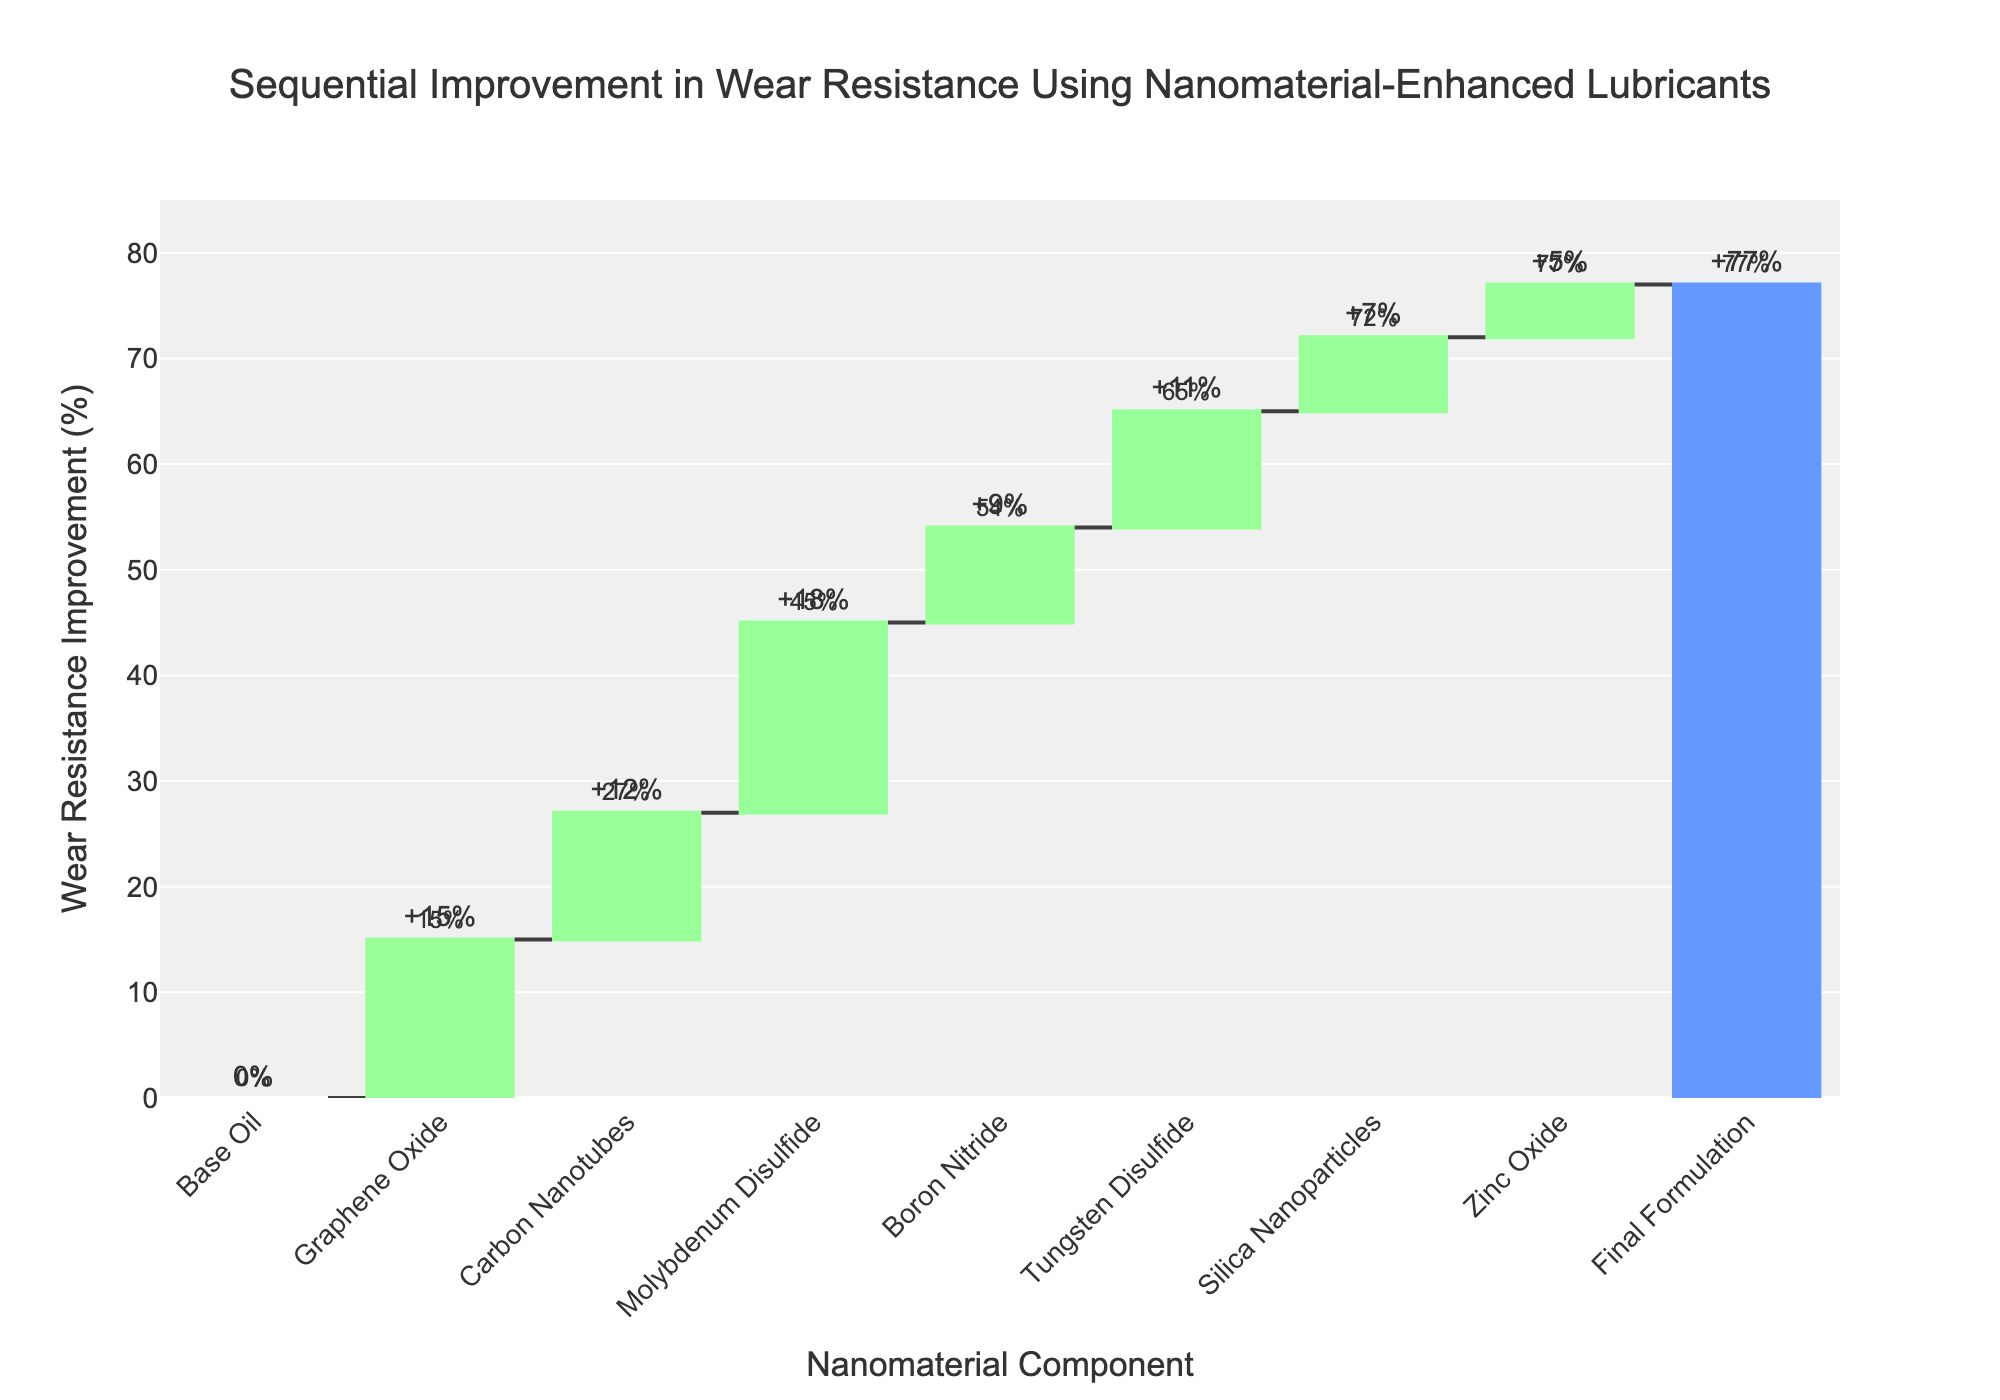What is the title of the chart? The title is usually at the top of the chart. In this case, it reads "Sequential Improvement in Wear Resistance Using Nanomaterial-Enhanced Lubricants".
Answer: Sequential Improvement in Wear Resistance Using Nanomaterial-Enhanced Lubricants What is the total improvement in wear resistance after using all nanomaterial-enhanced lubricants? The total improvement can be found by looking at the last column labeled "Final Formulation", where the text and y-axis both indicate the total improvement in wear resistance.
Answer: 77% Which nanomaterial component contributes the highest percentage improvement in wear resistance? By checking each bar's height or label, you can see that Molybdenum Disulfide has the highest individual percentage improvement at 18%.
Answer: Molybdenum Disulfide What is the combined wear resistance improvement of Carbon Nanotubes and Boron Nitride? Combine the individual improvements: 12% for Carbon Nanotubes and 9% for Boron Nitride to get the total of 21%.
Answer: 21% What is the running total of wear resistance improvement after adding Carbon Nanotubes? According to the "Running Total (%)" value next to Carbon Nanotubes, the cumulative improvement is 27% at this stage.
Answer: 27% Which component showed the least improvement in wear resistance? Comparing all nanomaterial components by their improvement percentages, Zinc Oxide showed the least improvement with just 5%.
Answer: Zinc Oxide What is the difference in wear resistance improvement between Graphene Oxide and Tungsten Disulfide? Subtract the improvement percentage of Graphene Oxide (15%) from that of Tungsten Disulfide (11%) to get the difference: 15% - 11% = 4%.
Answer: 4% What is the wear resistance improvement after adding three components: Graphene Oxide, Carbon Nanotubes, and Molybdenum Disulfide? Sum up the individual improvements of these three: 15% + 12% + 18% = 45%.
Answer: 45% After how many components does the cumulative wear resistance improvement cross 50%? Check the running totals for each component. It crosses 50% after Molybdenum Disulfide, and the running total at Boron Nitride is 54%. This indicates that after adding Boron Nitride (4 components), it crosses 50%.
Answer: 4 components What color represents increasing improvements in the chart? The color representing increasing improvements is specified as light green in the chart description.
Answer: Light green 